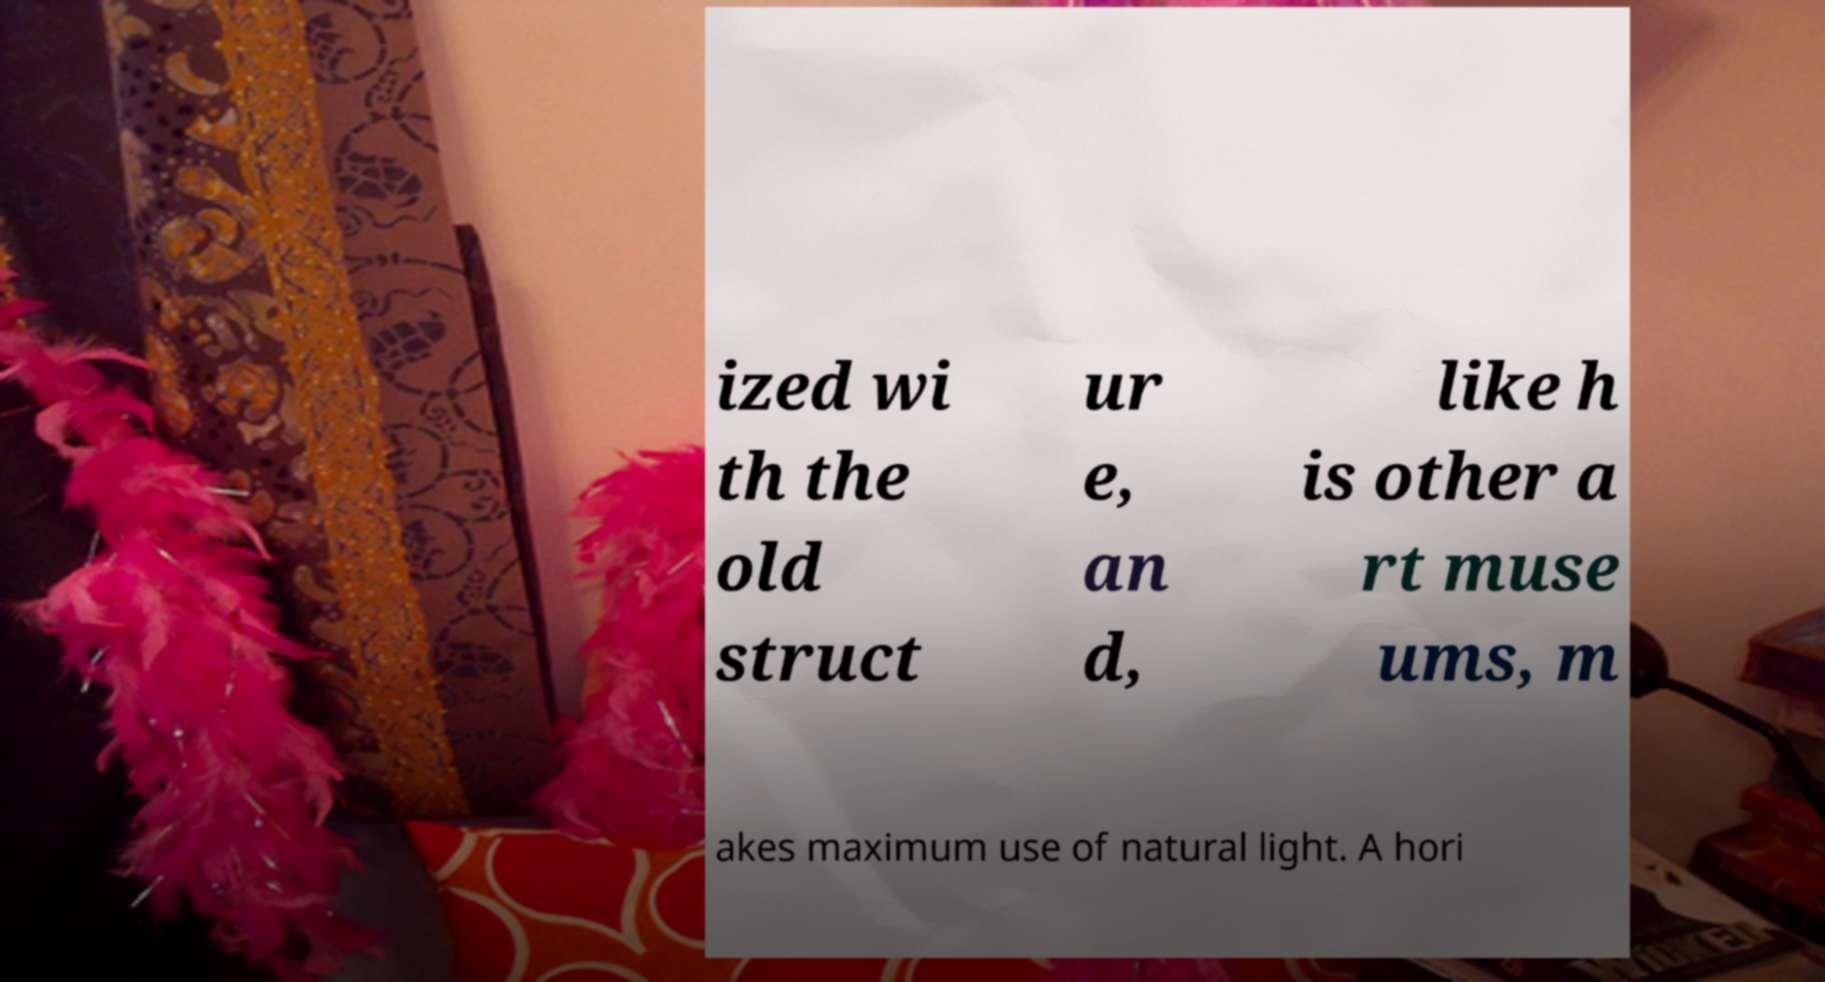I need the written content from this picture converted into text. Can you do that? ized wi th the old struct ur e, an d, like h is other a rt muse ums, m akes maximum use of natural light. A hori 